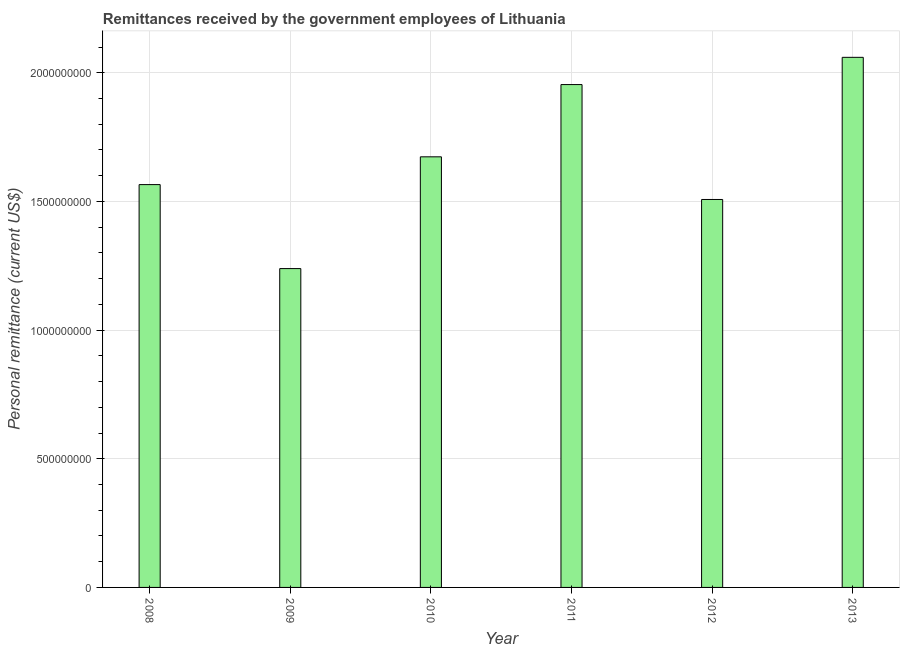What is the title of the graph?
Offer a very short reply. Remittances received by the government employees of Lithuania. What is the label or title of the X-axis?
Offer a terse response. Year. What is the label or title of the Y-axis?
Your answer should be very brief. Personal remittance (current US$). What is the personal remittances in 2010?
Make the answer very short. 1.67e+09. Across all years, what is the maximum personal remittances?
Offer a very short reply. 2.06e+09. Across all years, what is the minimum personal remittances?
Offer a very short reply. 1.24e+09. In which year was the personal remittances minimum?
Your response must be concise. 2009. What is the sum of the personal remittances?
Ensure brevity in your answer.  1.00e+1. What is the difference between the personal remittances in 2011 and 2013?
Your answer should be very brief. -1.06e+08. What is the average personal remittances per year?
Provide a succinct answer. 1.67e+09. What is the median personal remittances?
Your answer should be very brief. 1.62e+09. What is the ratio of the personal remittances in 2009 to that in 2013?
Provide a succinct answer. 0.6. What is the difference between the highest and the second highest personal remittances?
Offer a terse response. 1.06e+08. What is the difference between the highest and the lowest personal remittances?
Offer a very short reply. 8.21e+08. In how many years, is the personal remittances greater than the average personal remittances taken over all years?
Your answer should be compact. 3. Are all the bars in the graph horizontal?
Provide a short and direct response. No. What is the Personal remittance (current US$) of 2008?
Your answer should be compact. 1.57e+09. What is the Personal remittance (current US$) of 2009?
Keep it short and to the point. 1.24e+09. What is the Personal remittance (current US$) of 2010?
Your answer should be compact. 1.67e+09. What is the Personal remittance (current US$) of 2011?
Offer a very short reply. 1.95e+09. What is the Personal remittance (current US$) in 2012?
Offer a very short reply. 1.51e+09. What is the Personal remittance (current US$) in 2013?
Offer a very short reply. 2.06e+09. What is the difference between the Personal remittance (current US$) in 2008 and 2009?
Provide a short and direct response. 3.26e+08. What is the difference between the Personal remittance (current US$) in 2008 and 2010?
Make the answer very short. -1.08e+08. What is the difference between the Personal remittance (current US$) in 2008 and 2011?
Your answer should be very brief. -3.89e+08. What is the difference between the Personal remittance (current US$) in 2008 and 2012?
Give a very brief answer. 5.78e+07. What is the difference between the Personal remittance (current US$) in 2008 and 2013?
Provide a succinct answer. -4.95e+08. What is the difference between the Personal remittance (current US$) in 2009 and 2010?
Give a very brief answer. -4.34e+08. What is the difference between the Personal remittance (current US$) in 2009 and 2011?
Offer a very short reply. -7.15e+08. What is the difference between the Personal remittance (current US$) in 2009 and 2012?
Offer a very short reply. -2.69e+08. What is the difference between the Personal remittance (current US$) in 2009 and 2013?
Keep it short and to the point. -8.21e+08. What is the difference between the Personal remittance (current US$) in 2010 and 2011?
Offer a very short reply. -2.81e+08. What is the difference between the Personal remittance (current US$) in 2010 and 2012?
Provide a succinct answer. 1.66e+08. What is the difference between the Personal remittance (current US$) in 2010 and 2013?
Offer a terse response. -3.87e+08. What is the difference between the Personal remittance (current US$) in 2011 and 2012?
Offer a terse response. 4.47e+08. What is the difference between the Personal remittance (current US$) in 2011 and 2013?
Keep it short and to the point. -1.06e+08. What is the difference between the Personal remittance (current US$) in 2012 and 2013?
Ensure brevity in your answer.  -5.52e+08. What is the ratio of the Personal remittance (current US$) in 2008 to that in 2009?
Ensure brevity in your answer.  1.26. What is the ratio of the Personal remittance (current US$) in 2008 to that in 2010?
Your answer should be compact. 0.94. What is the ratio of the Personal remittance (current US$) in 2008 to that in 2011?
Give a very brief answer. 0.8. What is the ratio of the Personal remittance (current US$) in 2008 to that in 2012?
Keep it short and to the point. 1.04. What is the ratio of the Personal remittance (current US$) in 2008 to that in 2013?
Your answer should be very brief. 0.76. What is the ratio of the Personal remittance (current US$) in 2009 to that in 2010?
Offer a very short reply. 0.74. What is the ratio of the Personal remittance (current US$) in 2009 to that in 2011?
Your answer should be very brief. 0.63. What is the ratio of the Personal remittance (current US$) in 2009 to that in 2012?
Your answer should be compact. 0.82. What is the ratio of the Personal remittance (current US$) in 2009 to that in 2013?
Give a very brief answer. 0.6. What is the ratio of the Personal remittance (current US$) in 2010 to that in 2011?
Offer a terse response. 0.86. What is the ratio of the Personal remittance (current US$) in 2010 to that in 2012?
Provide a succinct answer. 1.11. What is the ratio of the Personal remittance (current US$) in 2010 to that in 2013?
Offer a terse response. 0.81. What is the ratio of the Personal remittance (current US$) in 2011 to that in 2012?
Make the answer very short. 1.3. What is the ratio of the Personal remittance (current US$) in 2011 to that in 2013?
Offer a very short reply. 0.95. What is the ratio of the Personal remittance (current US$) in 2012 to that in 2013?
Give a very brief answer. 0.73. 